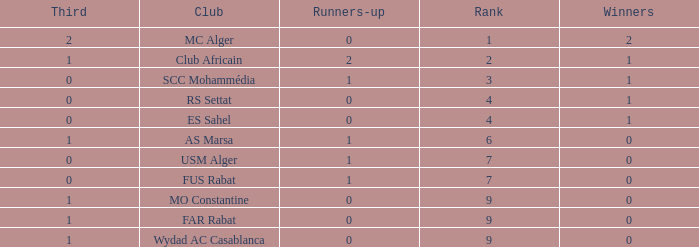How many Winners have a Third of 1, and Runners-up smaller than 0? 0.0. 